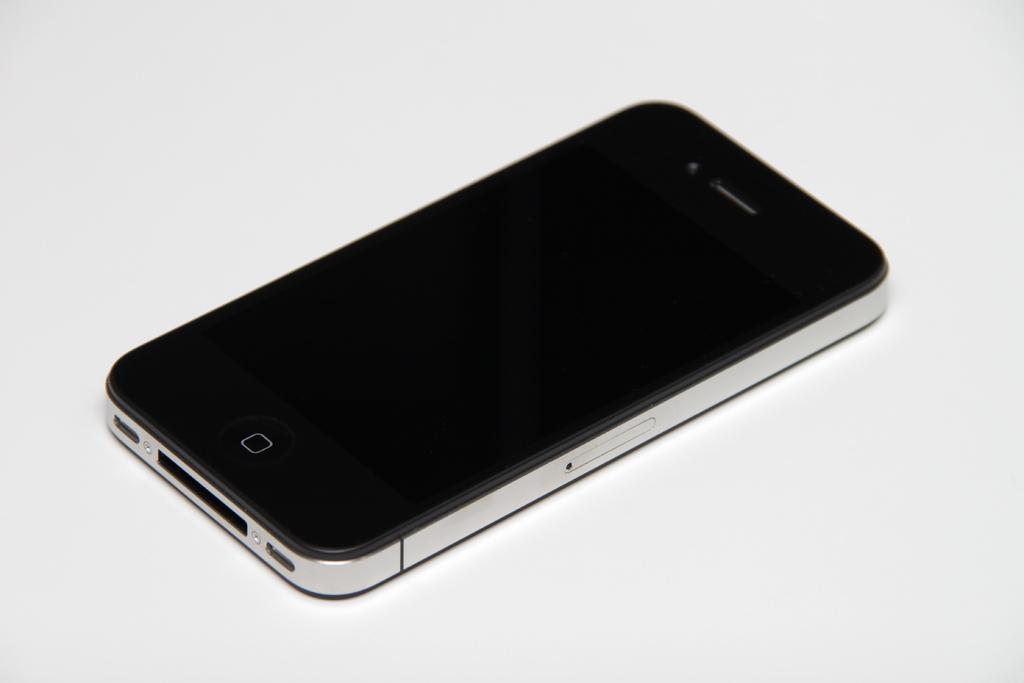In one or two sentences, can you explain what this image depicts? In this picture I can see a mobile on an object. 